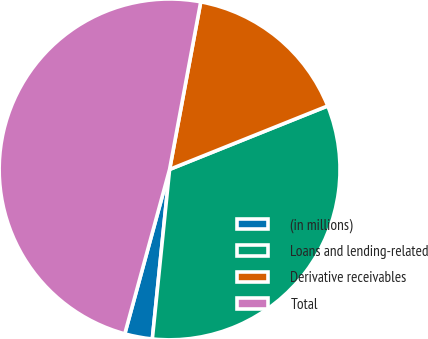Convert chart. <chart><loc_0><loc_0><loc_500><loc_500><pie_chart><fcel>(in millions)<fcel>Loans and lending-related<fcel>Derivative receivables<fcel>Total<nl><fcel>2.62%<fcel>32.69%<fcel>16.0%<fcel>48.69%<nl></chart> 